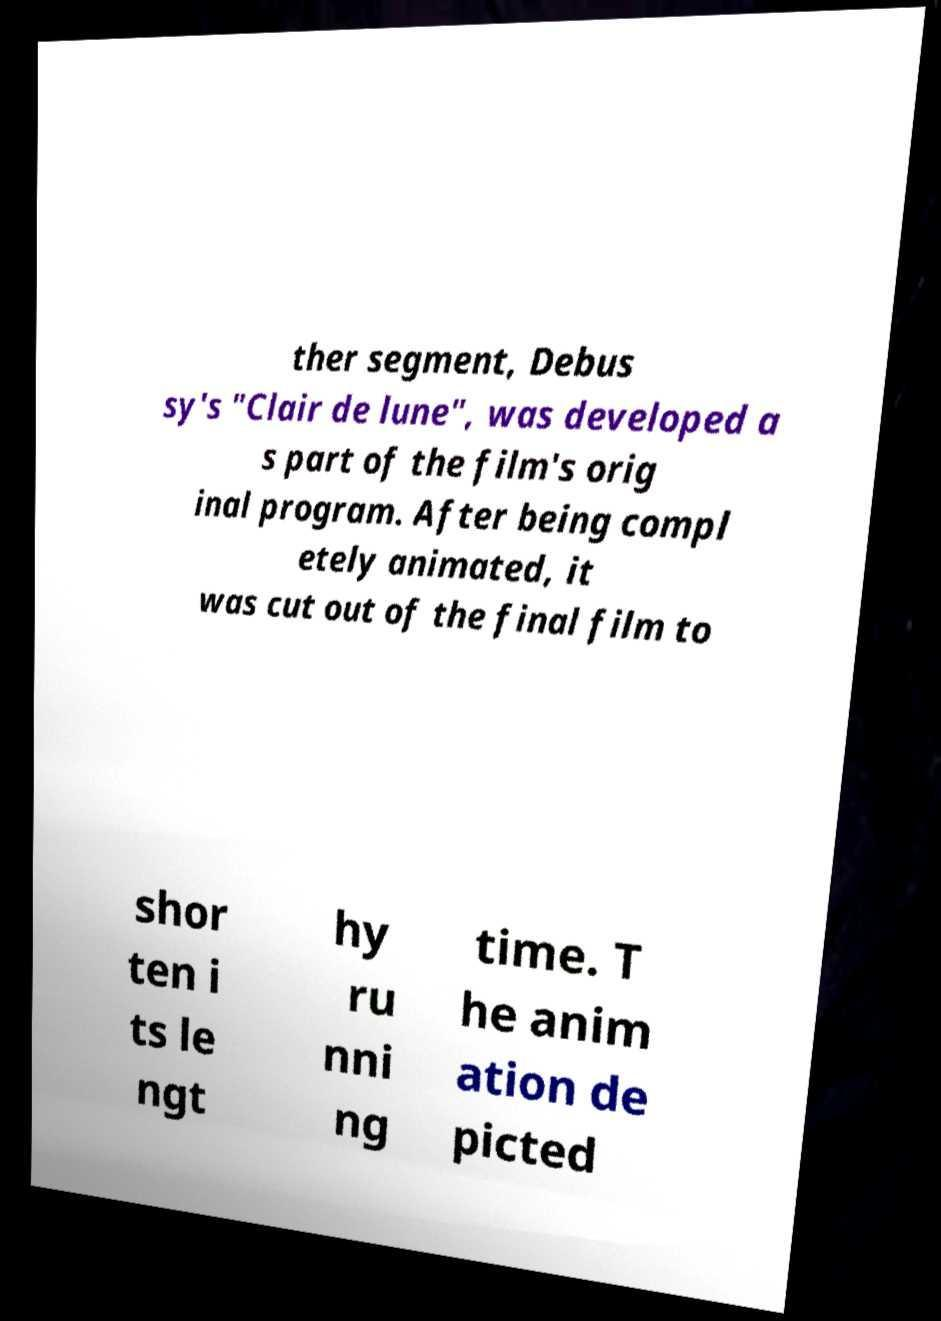What messages or text are displayed in this image? I need them in a readable, typed format. ther segment, Debus sy's "Clair de lune", was developed a s part of the film's orig inal program. After being compl etely animated, it was cut out of the final film to shor ten i ts le ngt hy ru nni ng time. T he anim ation de picted 